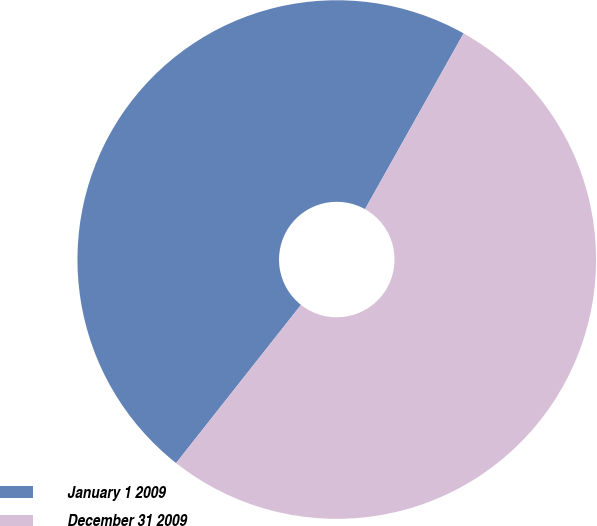<chart> <loc_0><loc_0><loc_500><loc_500><pie_chart><fcel>January 1 2009<fcel>December 31 2009<nl><fcel>47.5%<fcel>52.5%<nl></chart> 